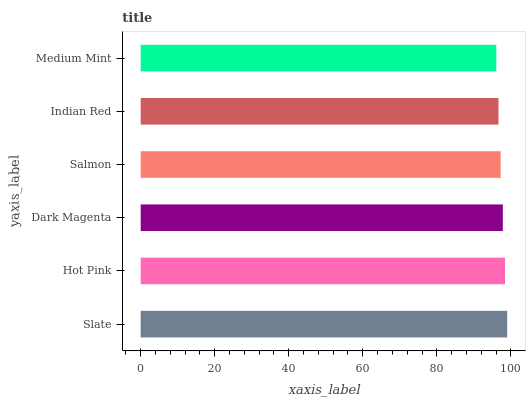Is Medium Mint the minimum?
Answer yes or no. Yes. Is Slate the maximum?
Answer yes or no. Yes. Is Hot Pink the minimum?
Answer yes or no. No. Is Hot Pink the maximum?
Answer yes or no. No. Is Slate greater than Hot Pink?
Answer yes or no. Yes. Is Hot Pink less than Slate?
Answer yes or no. Yes. Is Hot Pink greater than Slate?
Answer yes or no. No. Is Slate less than Hot Pink?
Answer yes or no. No. Is Dark Magenta the high median?
Answer yes or no. Yes. Is Salmon the low median?
Answer yes or no. Yes. Is Salmon the high median?
Answer yes or no. No. Is Hot Pink the low median?
Answer yes or no. No. 